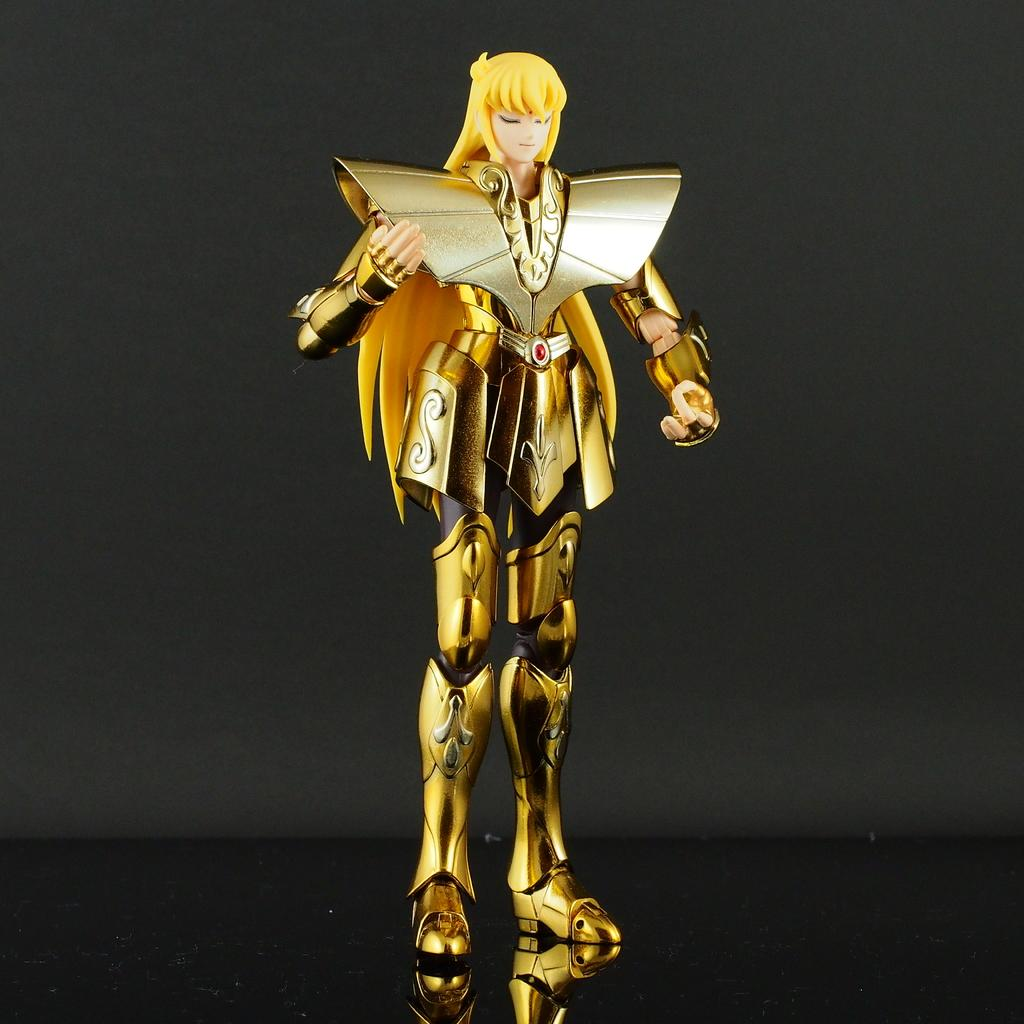What is the main object in the image? There is a toy in the image. What distinguishes this toy from others? The toy has a costume. Where is the toy with the costume located? The toy with the costume is placed over a surface. What type of guitar is the toy playing in the image? There is no guitar present in the image; it features a toy with a costume placed over a surface. 